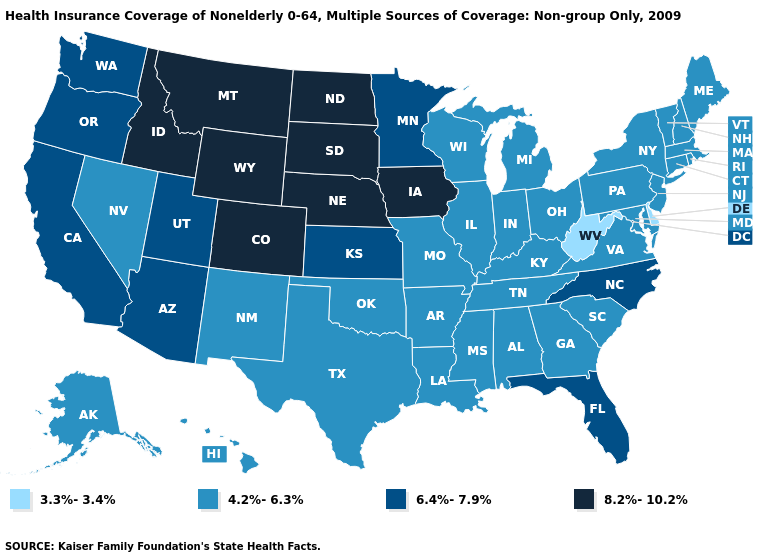Name the states that have a value in the range 6.4%-7.9%?
Short answer required. Arizona, California, Florida, Kansas, Minnesota, North Carolina, Oregon, Utah, Washington. Does Virginia have the lowest value in the USA?
Be succinct. No. Among the states that border Kansas , does Oklahoma have the highest value?
Quick response, please. No. Does the map have missing data?
Be succinct. No. Does the first symbol in the legend represent the smallest category?
Be succinct. Yes. Name the states that have a value in the range 6.4%-7.9%?
Short answer required. Arizona, California, Florida, Kansas, Minnesota, North Carolina, Oregon, Utah, Washington. What is the value of Nebraska?
Short answer required. 8.2%-10.2%. Does the map have missing data?
Answer briefly. No. Does Oregon have a higher value than Minnesota?
Concise answer only. No. Which states have the highest value in the USA?
Quick response, please. Colorado, Idaho, Iowa, Montana, Nebraska, North Dakota, South Dakota, Wyoming. Does California have a lower value than Wyoming?
Quick response, please. Yes. Which states have the lowest value in the USA?
Keep it brief. Delaware, West Virginia. Name the states that have a value in the range 6.4%-7.9%?
Keep it brief. Arizona, California, Florida, Kansas, Minnesota, North Carolina, Oregon, Utah, Washington. Name the states that have a value in the range 4.2%-6.3%?
Short answer required. Alabama, Alaska, Arkansas, Connecticut, Georgia, Hawaii, Illinois, Indiana, Kentucky, Louisiana, Maine, Maryland, Massachusetts, Michigan, Mississippi, Missouri, Nevada, New Hampshire, New Jersey, New Mexico, New York, Ohio, Oklahoma, Pennsylvania, Rhode Island, South Carolina, Tennessee, Texas, Vermont, Virginia, Wisconsin. Name the states that have a value in the range 3.3%-3.4%?
Be succinct. Delaware, West Virginia. 